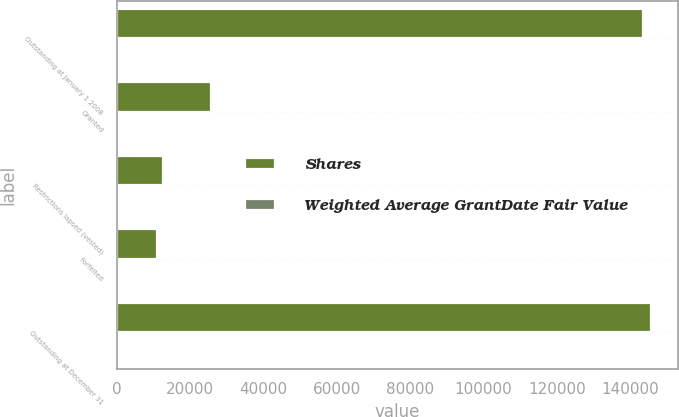Convert chart to OTSL. <chart><loc_0><loc_0><loc_500><loc_500><stacked_bar_chart><ecel><fcel>Outstanding at January 1 2008<fcel>Granted<fcel>Restrictions lapsed (vested)<fcel>Forfeited<fcel>Outstanding at December 31<nl><fcel>Shares<fcel>143609<fcel>25698<fcel>12609<fcel>11020<fcel>145678<nl><fcel>Weighted Average GrantDate Fair Value<fcel>26.92<fcel>121.17<fcel>38.21<fcel>32.81<fcel>42.13<nl></chart> 